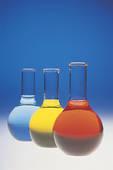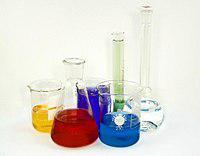The first image is the image on the left, the second image is the image on the right. For the images displayed, is the sentence "An image shows an angled row of three of the same type of container shapes, with different colored liquids inside." factually correct? Answer yes or no. Yes. The first image is the image on the left, the second image is the image on the right. For the images displayed, is the sentence "Four vases in the image on the left are filled with blue liquid." factually correct? Answer yes or no. No. 